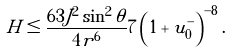Convert formula to latex. <formula><loc_0><loc_0><loc_500><loc_500>H \leq \frac { 6 3 J ^ { 2 } \sin ^ { 2 } \theta } { 4 r ^ { 6 } } 7 \left ( 1 + u ^ { - } _ { 0 } \right ) ^ { - 8 } .</formula> 